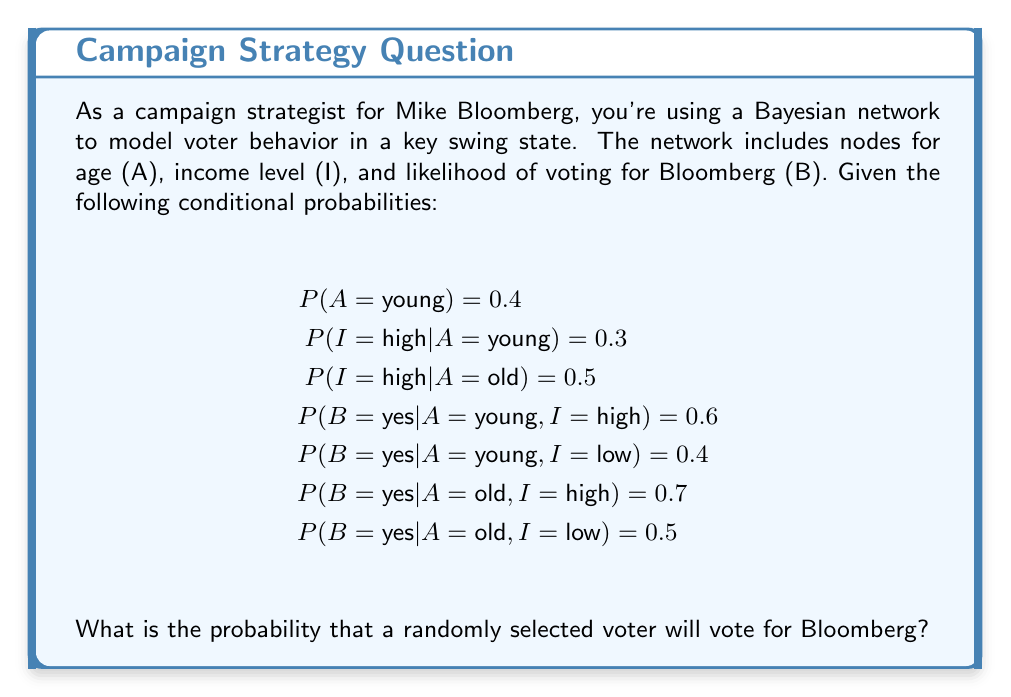Help me with this question. To solve this problem, we need to use the law of total probability and the given conditional probabilities in the Bayesian network. Let's break it down step by step:

1) First, we need to calculate $P(I = \text{high})$ using the law of total probability:

   $P(I = \text{high}) = P(I = \text{high} | A = \text{young}) \cdot P(A = \text{young}) + P(I = \text{high} | A = \text{old}) \cdot P(A = \text{old})$

   $P(I = \text{high}) = 0.3 \cdot 0.4 + 0.5 \cdot 0.6 = 0.12 + 0.3 = 0.42$

2) Now, we can calculate $P(B = \text{yes})$ using the law of total probability again:

   $P(B = \text{yes}) = P(B = \text{yes} | A = \text{young}, I = \text{high}) \cdot P(A = \text{young}) \cdot P(I = \text{high}) +$
                       $P(B = \text{yes} | A = \text{young}, I = \text{low}) \cdot P(A = \text{young}) \cdot P(I = \text{low}) +$
                       $P(B = \text{yes} | A = \text{old}, I = \text{high}) \cdot P(A = \text{old}) \cdot P(I = \text{high}) +$
                       $P(B = \text{yes} | A = \text{old}, I = \text{low}) \cdot P(A = \text{old}) \cdot P(I = \text{low})$

3) Let's substitute the values:

   $P(B = \text{yes}) = 0.6 \cdot 0.4 \cdot 0.42 + 0.4 \cdot 0.4 \cdot 0.58 + 0.7 \cdot 0.6 \cdot 0.42 + 0.5 \cdot 0.6 \cdot 0.58$

4) Now, let's calculate each term:

   $0.6 \cdot 0.4 \cdot 0.42 = 0.1008$
   $0.4 \cdot 0.4 \cdot 0.58 = 0.0928$
   $0.7 \cdot 0.6 \cdot 0.42 = 0.1764$
   $0.5 \cdot 0.6 \cdot 0.58 = 0.1740$

5) Sum up all terms:

   $P(B = \text{yes}) = 0.1008 + 0.0928 + 0.1764 + 0.1740 = 0.5440$

Therefore, the probability that a randomly selected voter will vote for Bloomberg is 0.5440 or 54.40%.
Answer: $0.5440$ or $54.40\%$ 